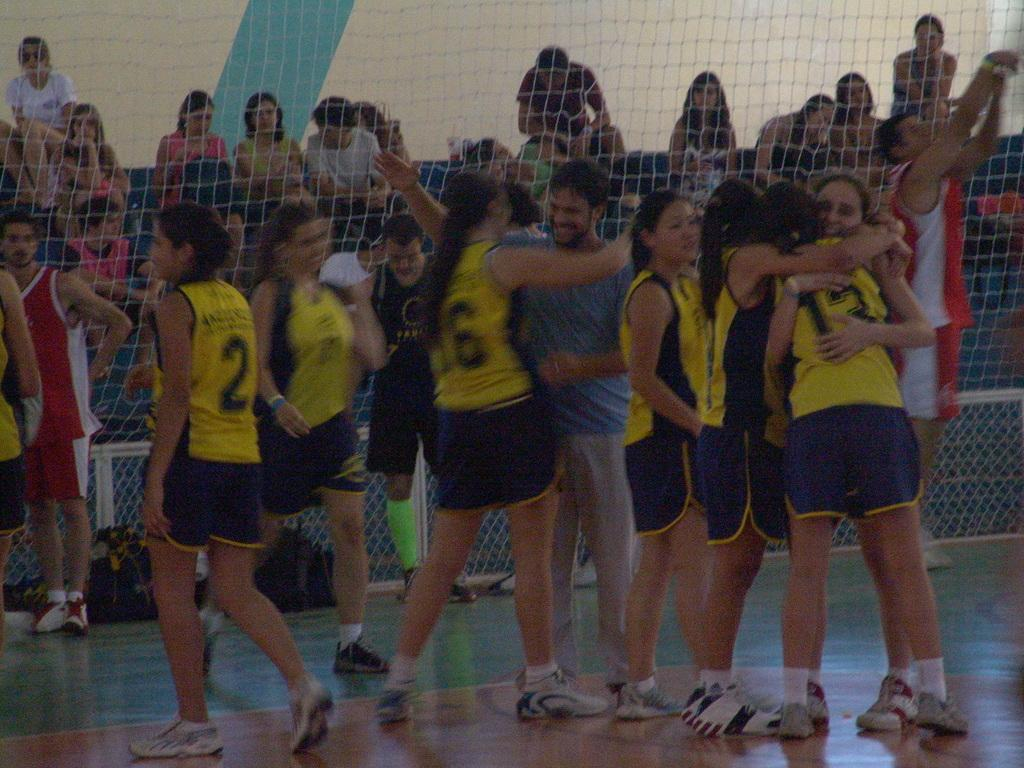What are the people in the image doing? There are people standing and hugging each other in the image. What can be seen in the background of the image? There is a mesh visible in the image. What are the people behind the mesh doing? There are people sitting behind the mesh. What objects are on the floor in the image? Bags are present on the floor in the image. What type of dust can be seen settling on the teeth of the people in the image? There is no dust or teeth visible in the image; it features people hugging each other and sitting behind a mesh. 